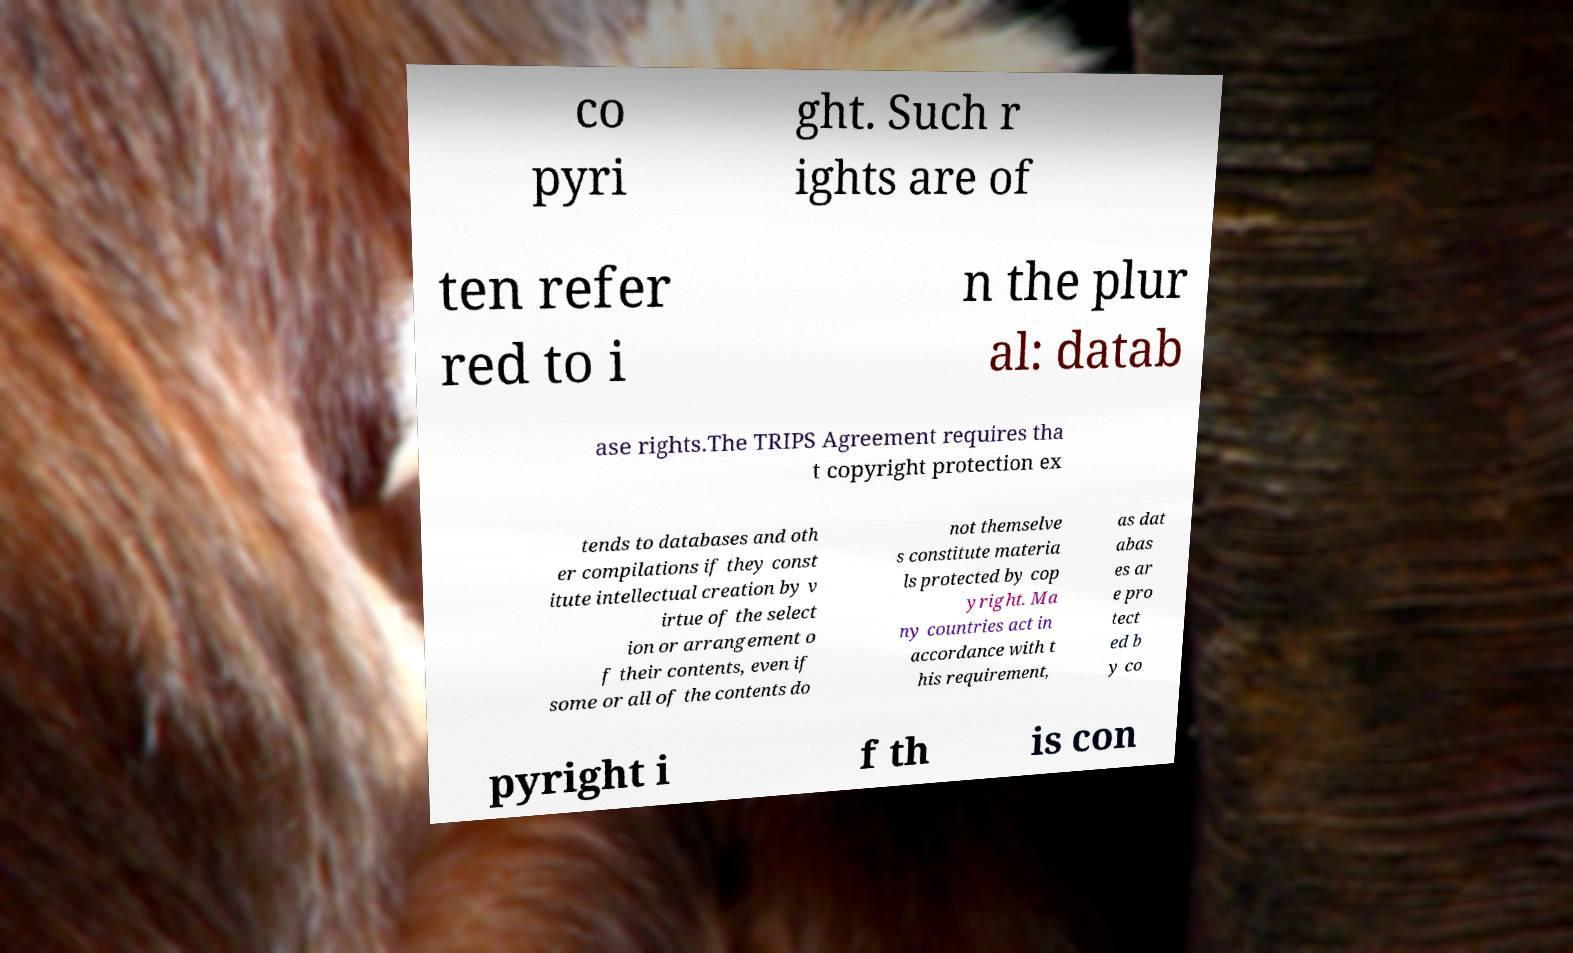What messages or text are displayed in this image? I need them in a readable, typed format. co pyri ght. Such r ights are of ten refer red to i n the plur al: datab ase rights.The TRIPS Agreement requires tha t copyright protection ex tends to databases and oth er compilations if they const itute intellectual creation by v irtue of the select ion or arrangement o f their contents, even if some or all of the contents do not themselve s constitute materia ls protected by cop yright. Ma ny countries act in accordance with t his requirement, as dat abas es ar e pro tect ed b y co pyright i f th is con 